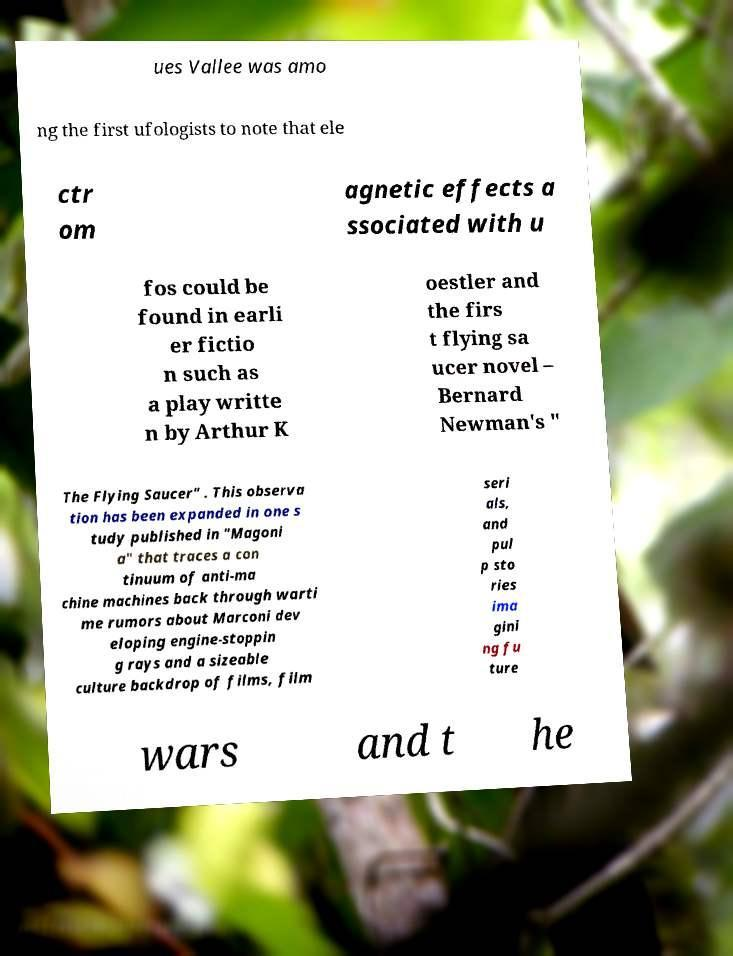There's text embedded in this image that I need extracted. Can you transcribe it verbatim? ues Vallee was amo ng the first ufologists to note that ele ctr om agnetic effects a ssociated with u fos could be found in earli er fictio n such as a play writte n by Arthur K oestler and the firs t flying sa ucer novel – Bernard Newman's " The Flying Saucer" . This observa tion has been expanded in one s tudy published in "Magoni a" that traces a con tinuum of anti-ma chine machines back through warti me rumors about Marconi dev eloping engine-stoppin g rays and a sizeable culture backdrop of films, film seri als, and pul p sto ries ima gini ng fu ture wars and t he 